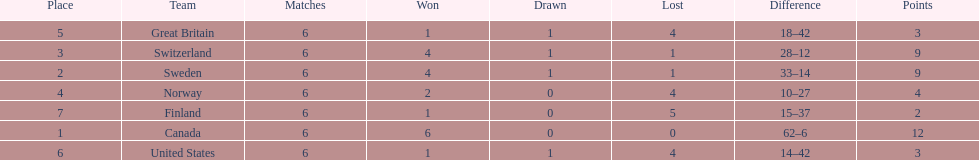Could you help me parse every detail presented in this table? {'header': ['Place', 'Team', 'Matches', 'Won', 'Drawn', 'Lost', 'Difference', 'Points'], 'rows': [['5', 'Great Britain', '6', '1', '1', '4', '18–42', '3'], ['3', 'Switzerland', '6', '4', '1', '1', '28–12', '9'], ['2', 'Sweden', '6', '4', '1', '1', '33–14', '9'], ['4', 'Norway', '6', '2', '0', '4', '10–27', '4'], ['7', 'Finland', '6', '1', '0', '5', '15–37', '2'], ['1', 'Canada', '6', '6', '0', '0', '62–6', '12'], ['6', 'United States', '6', '1', '1', '4', '14–42', '3']]} What team placed next after sweden? Switzerland. 